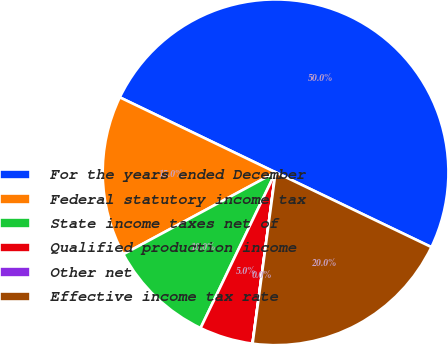Convert chart to OTSL. <chart><loc_0><loc_0><loc_500><loc_500><pie_chart><fcel>For the years ended December<fcel>Federal statutory income tax<fcel>State income taxes net of<fcel>Qualified production income<fcel>Other net<fcel>Effective income tax rate<nl><fcel>49.99%<fcel>15.0%<fcel>10.0%<fcel>5.01%<fcel>0.01%<fcel>20.0%<nl></chart> 